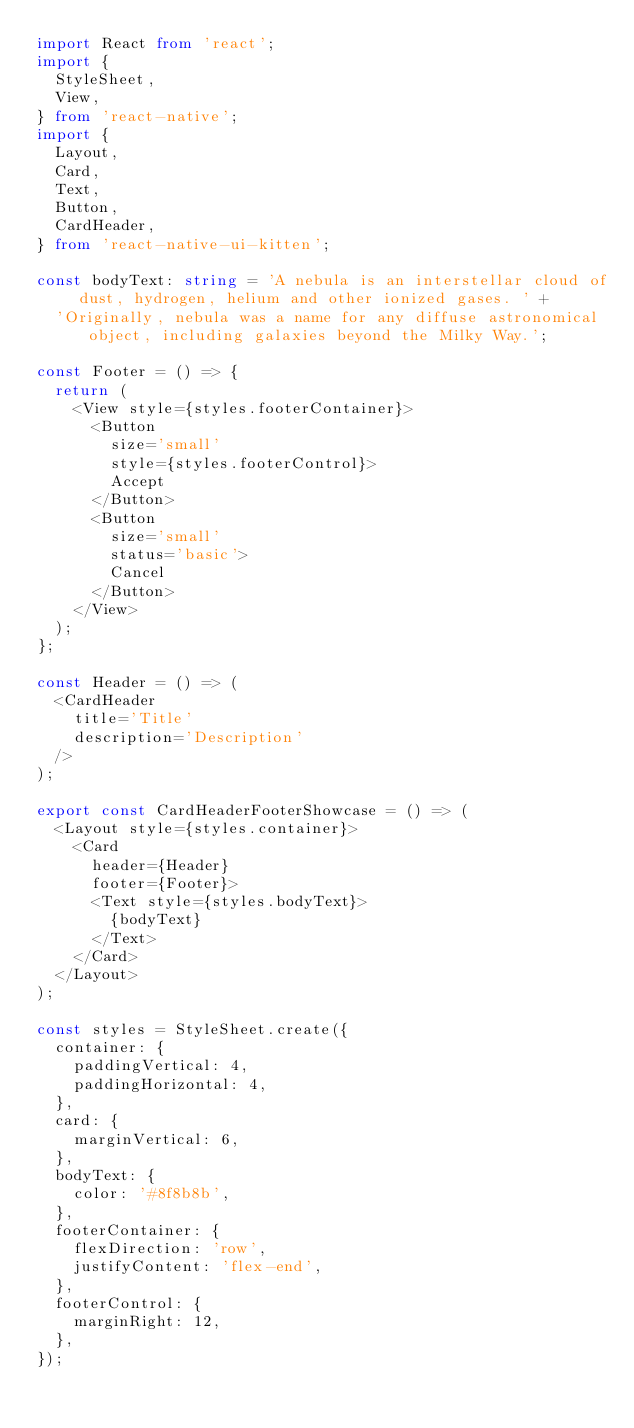Convert code to text. <code><loc_0><loc_0><loc_500><loc_500><_TypeScript_>import React from 'react';
import {
  StyleSheet,
  View,
} from 'react-native';
import {
  Layout,
  Card,
  Text,
  Button,
  CardHeader,
} from 'react-native-ui-kitten';

const bodyText: string = 'A nebula is an interstellar cloud of dust, hydrogen, helium and other ionized gases. ' +
  'Originally, nebula was a name for any diffuse astronomical object, including galaxies beyond the Milky Way.';

const Footer = () => {
  return (
    <View style={styles.footerContainer}>
      <Button
        size='small'
        style={styles.footerControl}>
        Accept
      </Button>
      <Button
        size='small'
        status='basic'>
        Cancel
      </Button>
    </View>
  );
};

const Header = () => (
  <CardHeader
    title='Title'
    description='Description'
  />
);

export const CardHeaderFooterShowcase = () => (
  <Layout style={styles.container}>
    <Card
      header={Header}
      footer={Footer}>
      <Text style={styles.bodyText}>
        {bodyText}
      </Text>
    </Card>
  </Layout>
);

const styles = StyleSheet.create({
  container: {
    paddingVertical: 4,
    paddingHorizontal: 4,
  },
  card: {
    marginVertical: 6,
  },
  bodyText: {
    color: '#8f8b8b',
  },
  footerContainer: {
    flexDirection: 'row',
    justifyContent: 'flex-end',
  },
  footerControl: {
    marginRight: 12,
  },
});
</code> 